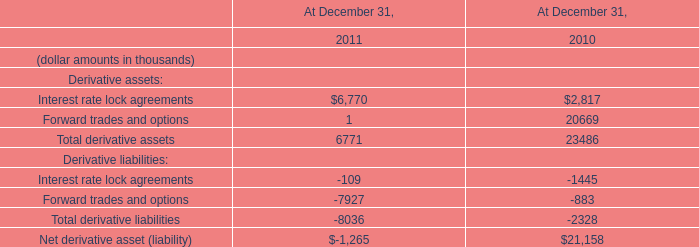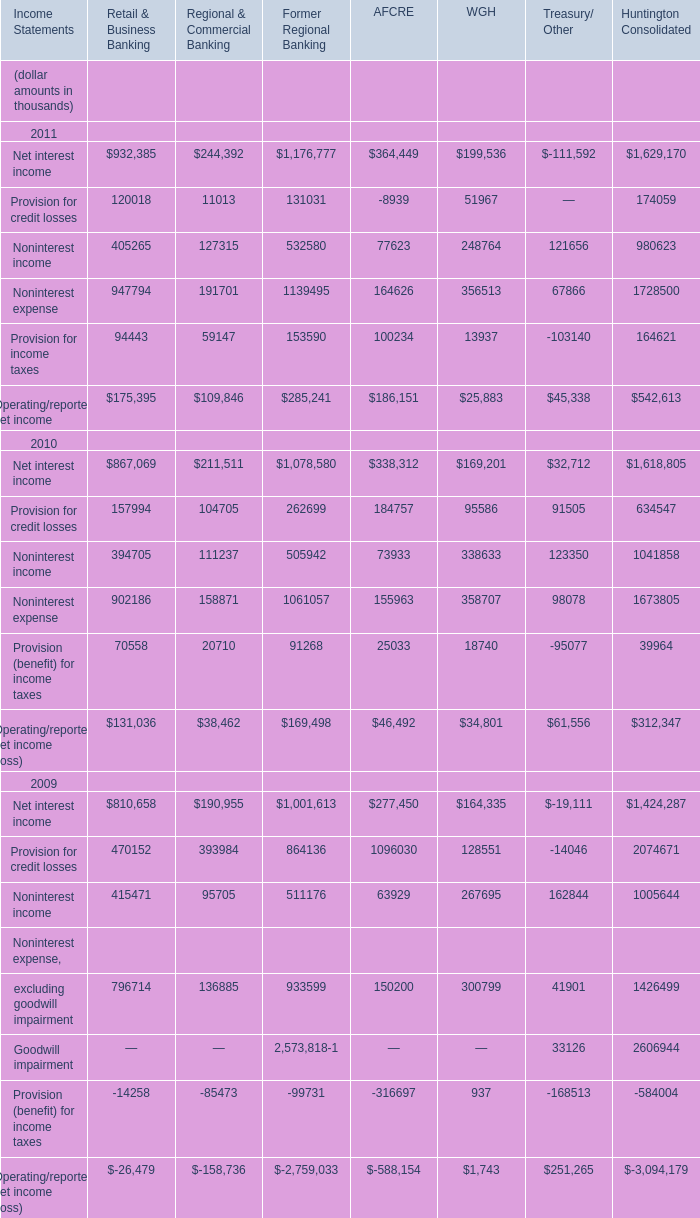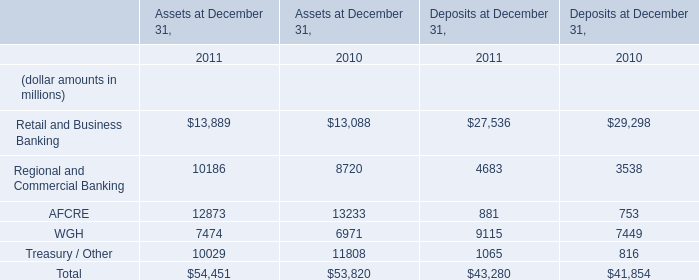What is the total amount of Interest rate lock agreements of At December 31, 2010, and Provision for credit losses of AFCRE ? 
Computations: (2817.0 + 8939.0)
Answer: 11756.0. 